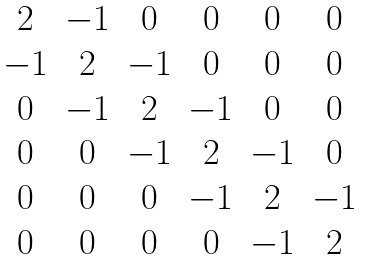<formula> <loc_0><loc_0><loc_500><loc_500>\begin{matrix} 2 & - 1 & 0 & 0 & 0 & 0 \\ - 1 & 2 & - 1 & 0 & 0 & 0 \\ 0 & - 1 & 2 & - 1 & 0 & 0 \\ 0 & 0 & - 1 & 2 & - 1 & 0 \\ 0 & 0 & 0 & - 1 & 2 & - 1 \\ 0 & 0 & 0 & 0 & - 1 & 2 \\ \end{matrix}</formula> 